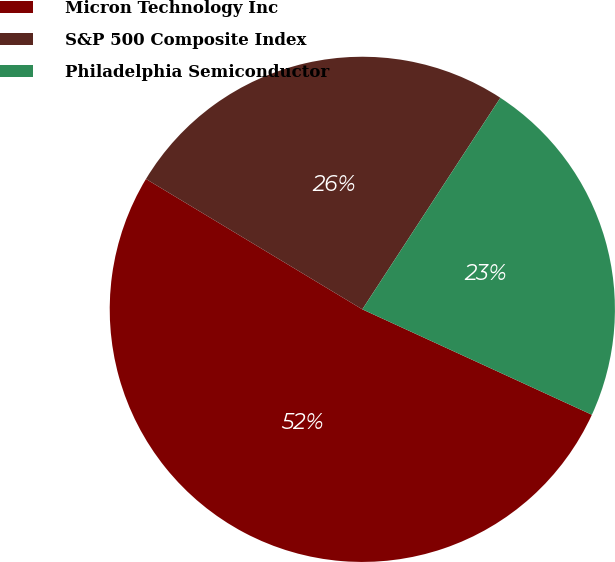Convert chart. <chart><loc_0><loc_0><loc_500><loc_500><pie_chart><fcel>Micron Technology Inc<fcel>S&P 500 Composite Index<fcel>Philadelphia Semiconductor<nl><fcel>51.78%<fcel>25.57%<fcel>22.65%<nl></chart> 